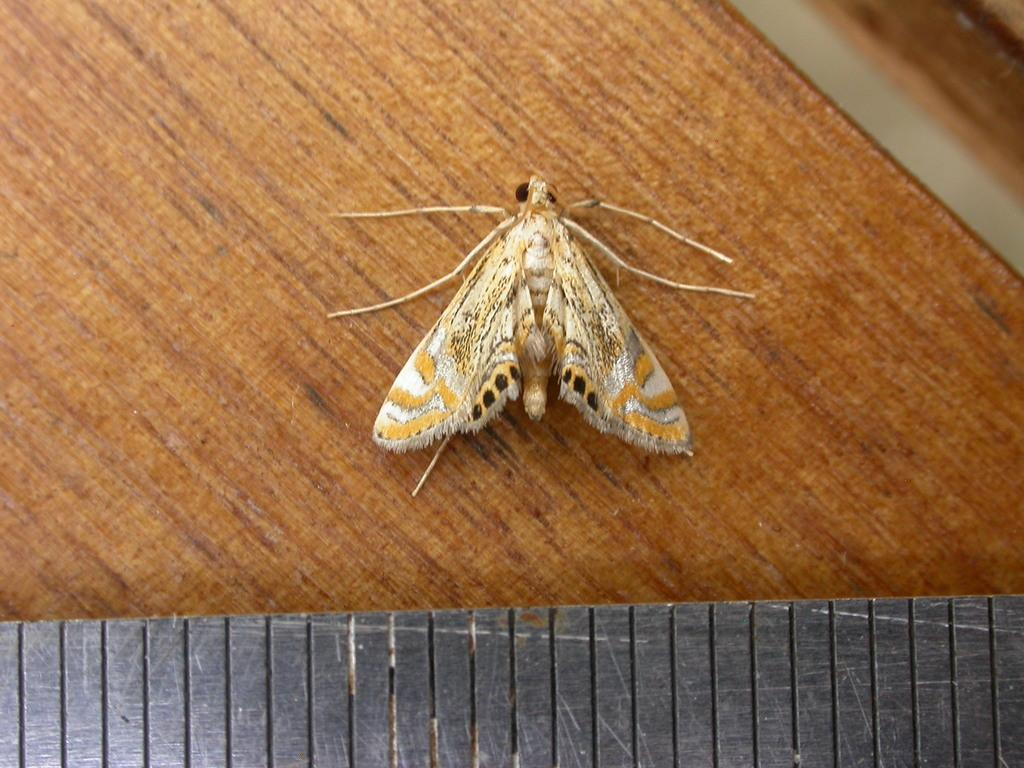What type of creature can be seen in the image? There is an insect in the image. Where is the insect located? The insect is on a wooden object. Are there any other wooden objects in the image? Yes, there is another wooden object at the bottom of the image. What type of crime is being committed by the insect in the image? There is no crime being committed by the insect in the image; it is simply an insect on a wooden object. Can you describe the eye of the insect in the image? There is no eye visible on the insect in the image, as insects typically have compound eyes that are difficult to discern in detail. 